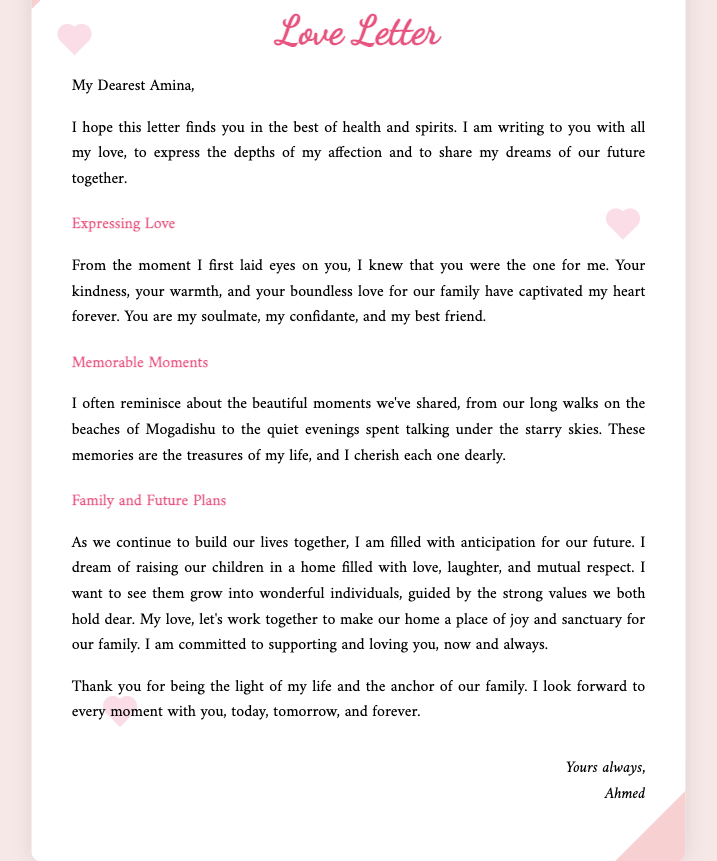what is the name of the spouse writing the letter? The letter is written by Ahmed, as stated at the end of the document.
Answer: Ahmed who is the recipient of the letter? The letter is addressed to Amina, mentioned at the beginning.
Answer: Amina what is the primary theme of the letter? The letter expresses affection and future plans, as indicated in the opening paragraphs and section titles.
Answer: Love and future plans which city is mentioned in relation to shared memories? Mogadishu is specifically mentioned when recalling long walks on the beaches.
Answer: Mogadishu what is one of the dreams expressed in the letter? Ahmed dreams of raising their children in a home filled with love, laughter, and mutual respect.
Answer: A home filled with love, laughter, and mutual respect what does Ahmed promise to Amina in the letter? He commits to supporting and loving her, indicating a lifelong dedication.
Answer: To support and love her how does Ahmed describe Amina's role in their family? He calls her the light of his life and the anchor of their family, showcasing her importance.
Answer: The light of my life and the anchor of our family what type of document is this? This document is a love letter, as indicated by the title and content.
Answer: Love letter 